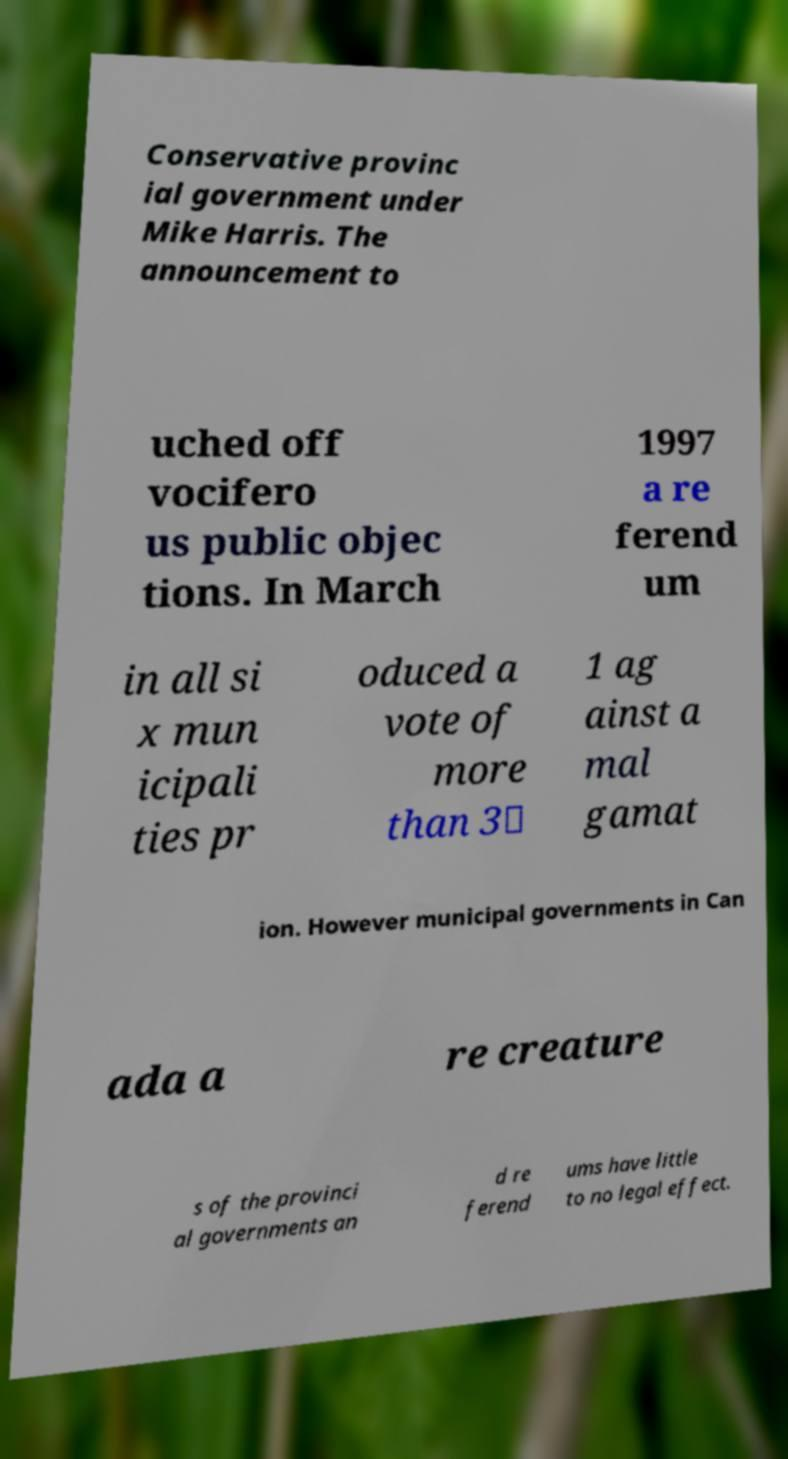Could you extract and type out the text from this image? Conservative provinc ial government under Mike Harris. The announcement to uched off vocifero us public objec tions. In March 1997 a re ferend um in all si x mun icipali ties pr oduced a vote of more than 3∶ 1 ag ainst a mal gamat ion. However municipal governments in Can ada a re creature s of the provinci al governments an d re ferend ums have little to no legal effect. 